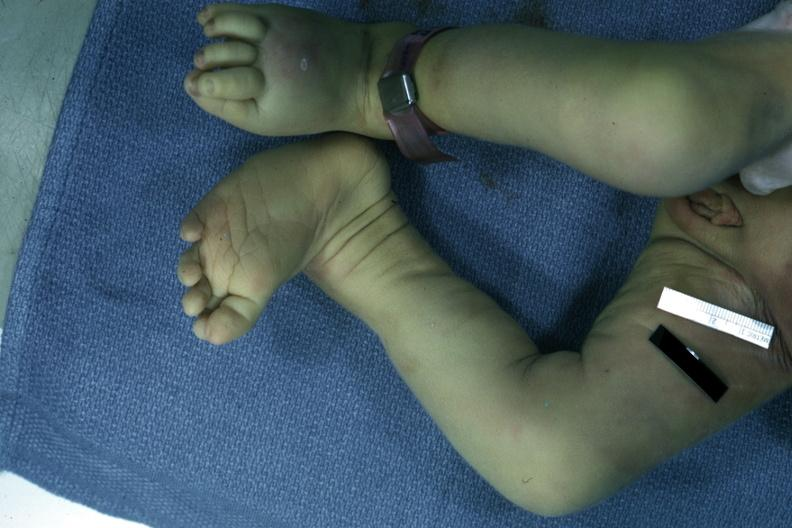what does this image show?
Answer the question using a single word or phrase. Autopsy left club foot 